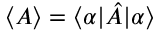Convert formula to latex. <formula><loc_0><loc_0><loc_500><loc_500>\langle A \rangle = \langle \alpha | \hat { A } | \alpha \rangle</formula> 